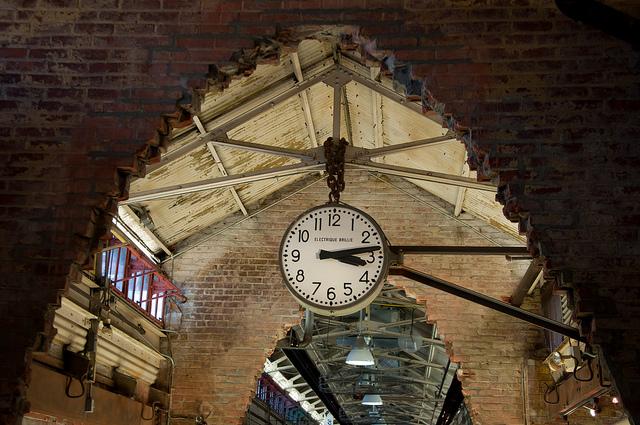What time is shown on the clock?
Short answer required. 3:13. How many people are there?
Be succinct. 0. Is this clock safely secured?
Be succinct. Yes. 